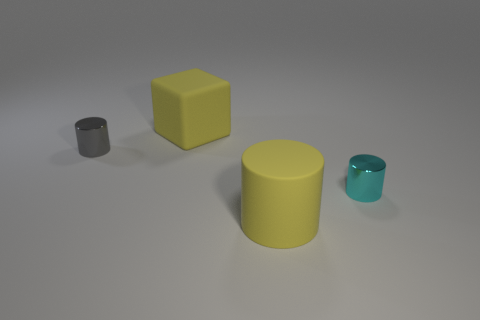What shape is the gray thing that is the same size as the cyan object? The gray object, which is the same size as the cyan object, is actually a cylinder with a circular base and a height that appears to be similar to its diameter. 